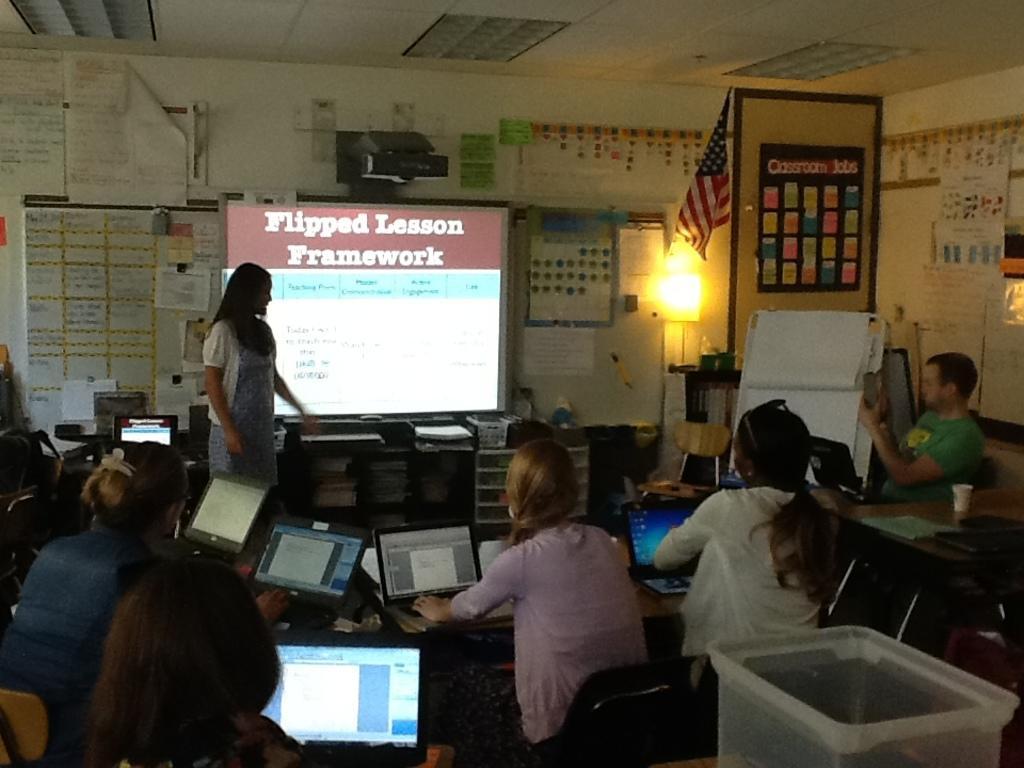Could you give a brief overview of what you see in this image? In this image there are some persons sitting with some laptops in the bottom of this image. there is one women standing on the left side of this image,and there is a screen in the middle of this image and there is a wall in the background as we can see there are some posters attached onto this wall,and there is a projector is on the top of this image. There is a flag and a light on the right side of this image. 